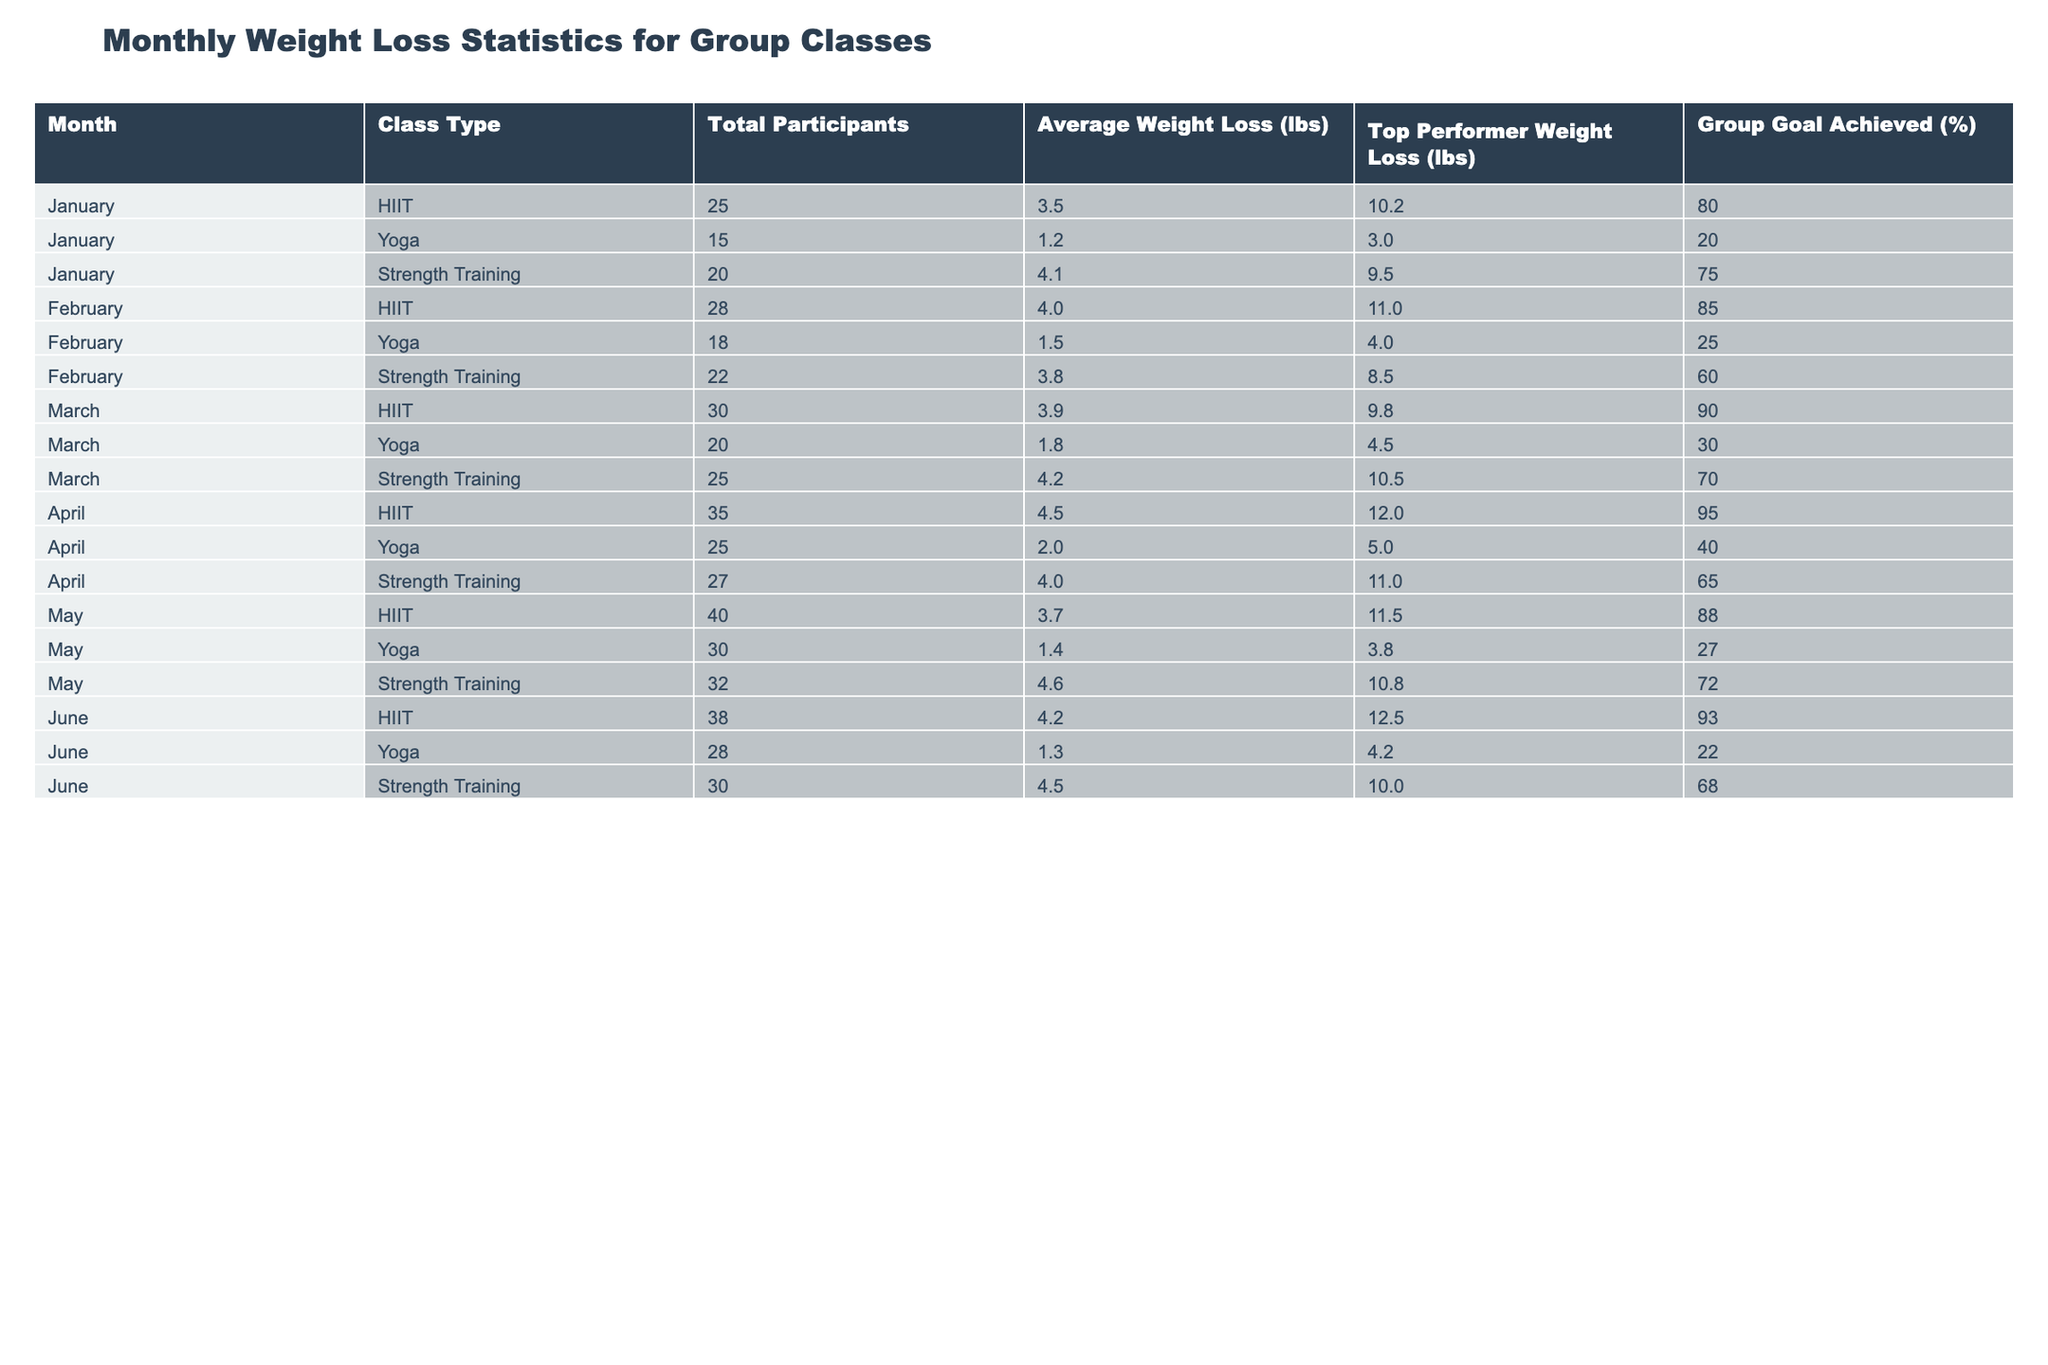What is the highest average weight loss recorded in a month? The maximum value in the "Average Weight Loss (lbs)" column is 4.6, which corresponds to May for the Strength Training class.
Answer: 4.6 lbs In which month did the Yoga class achieve the highest percentage of group goals? Observing the "Group Goal Achieved (%)" column for the Yoga class, the highest value is 40%, which is recorded in April.
Answer: April How many total participants were there in January across all class types? Adding the total participants for January: 25 (HIIT) + 15 (Yoga) + 20 (Strength Training) = 60.
Answer: 60 Which class had the top performer with the greatest weight loss in February? The "Top Performer Weight Loss (lbs)" column shows that the HIIT class had a top performer weight loss of 11.0 lbs in February, which is the highest for that month.
Answer: HIIT What is the average weight loss for the Strength Training class across all months? The average weight loss for Strength Training can be calculated by summing the average weight loss values: (4.1 + 3.8 + 4.2 + 4.0 + 4.6 + 4.5) = 25.2 lbs, and dividing by 6 (months) gives 25.2/6 = 4.2 lbs.
Answer: 4.2 lbs Is it true that the average weight loss for the HIIT class decreased from January to May? January's average loss was 3.5 lbs, while May's average loss was 3.7 lbs, showing an increase, so the statement is false.
Answer: False What are the top performer's weights lost in March for both Yoga and Strength Training? The "Top Performer Weight Loss (lbs)" values for March indicate 4.5 lbs for Yoga and 10.5 lbs for Strength Training.
Answer: 4.5 lbs (Yoga), 10.5 lbs (Strength Training) How does the average weight loss in April for HIIT compare to the average in February? In April, the average weight loss for HIIT is 4.5 lbs, while in February it is 4.0 lbs, indicating an increase of 0.5 lbs.
Answer: Increased by 0.5 lbs Which month had the least percentage of group goal achieved in the Yoga class? Observing the "Group Goal Achieved (%)" for Yoga, January shows a 20% achievement, the lowest across all months.
Answer: January What is the difference in total participants for HIIT class between February and March? The participants for HIIT in February were 28 and in March were 30, so the difference is 30 - 28 = 2.
Answer: 2 participants Which class type had the least average weight loss percentage achieved over the reported months? By looking at the average values, Yoga had lower percentages (20%, 25%, 30%, 40%, 27%, 22%), making it the lowest performing class type compared to others.
Answer: Yoga 